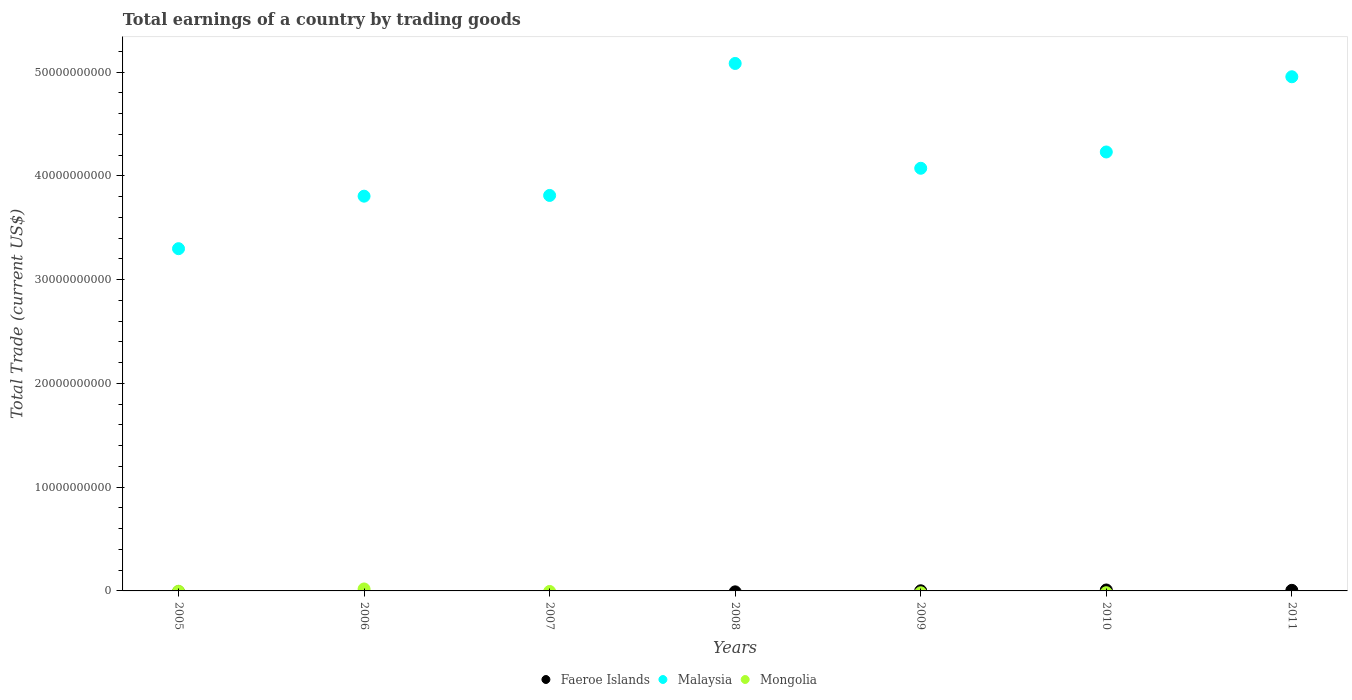How many different coloured dotlines are there?
Your answer should be compact. 3. What is the total earnings in Faeroe Islands in 2011?
Your response must be concise. 5.70e+07. Across all years, what is the maximum total earnings in Faeroe Islands?
Your response must be concise. 9.04e+07. Across all years, what is the minimum total earnings in Faeroe Islands?
Keep it short and to the point. 0. What is the total total earnings in Malaysia in the graph?
Provide a short and direct response. 2.93e+11. What is the difference between the total earnings in Malaysia in 2007 and that in 2011?
Give a very brief answer. -1.14e+1. What is the difference between the total earnings in Malaysia in 2011 and the total earnings in Mongolia in 2007?
Keep it short and to the point. 4.95e+1. What is the average total earnings in Malaysia per year?
Make the answer very short. 4.18e+1. In the year 2010, what is the difference between the total earnings in Faeroe Islands and total earnings in Malaysia?
Keep it short and to the point. -4.22e+1. In how many years, is the total earnings in Mongolia greater than 12000000000 US$?
Provide a succinct answer. 0. What is the ratio of the total earnings in Malaysia in 2005 to that in 2008?
Make the answer very short. 0.65. What is the difference between the highest and the second highest total earnings in Malaysia?
Provide a succinct answer. 1.28e+09. What is the difference between the highest and the lowest total earnings in Malaysia?
Make the answer very short. 1.78e+1. In how many years, is the total earnings in Mongolia greater than the average total earnings in Mongolia taken over all years?
Offer a very short reply. 1. Is the sum of the total earnings in Malaysia in 2005 and 2007 greater than the maximum total earnings in Mongolia across all years?
Ensure brevity in your answer.  Yes. Does the total earnings in Mongolia monotonically increase over the years?
Provide a short and direct response. No. Is the total earnings in Mongolia strictly greater than the total earnings in Malaysia over the years?
Offer a terse response. No. How many years are there in the graph?
Ensure brevity in your answer.  7. What is the difference between two consecutive major ticks on the Y-axis?
Provide a short and direct response. 1.00e+1. Are the values on the major ticks of Y-axis written in scientific E-notation?
Keep it short and to the point. No. Does the graph contain any zero values?
Provide a succinct answer. Yes. How many legend labels are there?
Your answer should be very brief. 3. What is the title of the graph?
Your answer should be very brief. Total earnings of a country by trading goods. What is the label or title of the Y-axis?
Offer a very short reply. Total Trade (current US$). What is the Total Trade (current US$) in Faeroe Islands in 2005?
Your answer should be very brief. 0. What is the Total Trade (current US$) of Malaysia in 2005?
Provide a short and direct response. 3.30e+1. What is the Total Trade (current US$) of Malaysia in 2006?
Make the answer very short. 3.80e+1. What is the Total Trade (current US$) in Mongolia in 2006?
Keep it short and to the point. 1.89e+08. What is the Total Trade (current US$) in Faeroe Islands in 2007?
Your answer should be very brief. 0. What is the Total Trade (current US$) in Malaysia in 2007?
Keep it short and to the point. 3.81e+1. What is the Total Trade (current US$) in Malaysia in 2008?
Your answer should be very brief. 5.08e+1. What is the Total Trade (current US$) in Mongolia in 2008?
Ensure brevity in your answer.  0. What is the Total Trade (current US$) in Faeroe Islands in 2009?
Offer a terse response. 1.31e+07. What is the Total Trade (current US$) of Malaysia in 2009?
Provide a succinct answer. 4.07e+1. What is the Total Trade (current US$) of Mongolia in 2009?
Ensure brevity in your answer.  0. What is the Total Trade (current US$) in Faeroe Islands in 2010?
Your answer should be compact. 9.04e+07. What is the Total Trade (current US$) of Malaysia in 2010?
Provide a short and direct response. 4.23e+1. What is the Total Trade (current US$) in Faeroe Islands in 2011?
Keep it short and to the point. 5.70e+07. What is the Total Trade (current US$) of Malaysia in 2011?
Offer a very short reply. 4.95e+1. What is the Total Trade (current US$) in Mongolia in 2011?
Ensure brevity in your answer.  0. Across all years, what is the maximum Total Trade (current US$) of Faeroe Islands?
Offer a very short reply. 9.04e+07. Across all years, what is the maximum Total Trade (current US$) in Malaysia?
Ensure brevity in your answer.  5.08e+1. Across all years, what is the maximum Total Trade (current US$) in Mongolia?
Keep it short and to the point. 1.89e+08. Across all years, what is the minimum Total Trade (current US$) of Faeroe Islands?
Ensure brevity in your answer.  0. Across all years, what is the minimum Total Trade (current US$) in Malaysia?
Offer a very short reply. 3.30e+1. What is the total Total Trade (current US$) in Faeroe Islands in the graph?
Your answer should be compact. 1.60e+08. What is the total Total Trade (current US$) of Malaysia in the graph?
Ensure brevity in your answer.  2.93e+11. What is the total Total Trade (current US$) of Mongolia in the graph?
Offer a terse response. 1.89e+08. What is the difference between the Total Trade (current US$) in Malaysia in 2005 and that in 2006?
Give a very brief answer. -5.06e+09. What is the difference between the Total Trade (current US$) in Malaysia in 2005 and that in 2007?
Offer a terse response. -5.13e+09. What is the difference between the Total Trade (current US$) of Malaysia in 2005 and that in 2008?
Make the answer very short. -1.78e+1. What is the difference between the Total Trade (current US$) of Malaysia in 2005 and that in 2009?
Your response must be concise. -7.75e+09. What is the difference between the Total Trade (current US$) in Malaysia in 2005 and that in 2010?
Your response must be concise. -9.32e+09. What is the difference between the Total Trade (current US$) in Malaysia in 2005 and that in 2011?
Make the answer very short. -1.66e+1. What is the difference between the Total Trade (current US$) in Malaysia in 2006 and that in 2007?
Your response must be concise. -7.12e+07. What is the difference between the Total Trade (current US$) of Malaysia in 2006 and that in 2008?
Your answer should be very brief. -1.28e+1. What is the difference between the Total Trade (current US$) of Malaysia in 2006 and that in 2009?
Your answer should be very brief. -2.69e+09. What is the difference between the Total Trade (current US$) of Malaysia in 2006 and that in 2010?
Your answer should be very brief. -4.26e+09. What is the difference between the Total Trade (current US$) of Malaysia in 2006 and that in 2011?
Keep it short and to the point. -1.15e+1. What is the difference between the Total Trade (current US$) in Malaysia in 2007 and that in 2008?
Provide a short and direct response. -1.27e+1. What is the difference between the Total Trade (current US$) of Malaysia in 2007 and that in 2009?
Ensure brevity in your answer.  -2.62e+09. What is the difference between the Total Trade (current US$) in Malaysia in 2007 and that in 2010?
Your response must be concise. -4.19e+09. What is the difference between the Total Trade (current US$) of Malaysia in 2007 and that in 2011?
Offer a terse response. -1.14e+1. What is the difference between the Total Trade (current US$) of Malaysia in 2008 and that in 2009?
Make the answer very short. 1.01e+1. What is the difference between the Total Trade (current US$) in Malaysia in 2008 and that in 2010?
Provide a succinct answer. 8.53e+09. What is the difference between the Total Trade (current US$) of Malaysia in 2008 and that in 2011?
Your answer should be very brief. 1.28e+09. What is the difference between the Total Trade (current US$) in Faeroe Islands in 2009 and that in 2010?
Keep it short and to the point. -7.74e+07. What is the difference between the Total Trade (current US$) in Malaysia in 2009 and that in 2010?
Give a very brief answer. -1.57e+09. What is the difference between the Total Trade (current US$) in Faeroe Islands in 2009 and that in 2011?
Make the answer very short. -4.39e+07. What is the difference between the Total Trade (current US$) of Malaysia in 2009 and that in 2011?
Make the answer very short. -8.82e+09. What is the difference between the Total Trade (current US$) in Faeroe Islands in 2010 and that in 2011?
Make the answer very short. 3.35e+07. What is the difference between the Total Trade (current US$) of Malaysia in 2010 and that in 2011?
Offer a very short reply. -7.25e+09. What is the difference between the Total Trade (current US$) in Malaysia in 2005 and the Total Trade (current US$) in Mongolia in 2006?
Your response must be concise. 3.28e+1. What is the difference between the Total Trade (current US$) of Faeroe Islands in 2009 and the Total Trade (current US$) of Malaysia in 2010?
Give a very brief answer. -4.23e+1. What is the difference between the Total Trade (current US$) in Faeroe Islands in 2009 and the Total Trade (current US$) in Malaysia in 2011?
Your answer should be very brief. -4.95e+1. What is the difference between the Total Trade (current US$) in Faeroe Islands in 2010 and the Total Trade (current US$) in Malaysia in 2011?
Provide a succinct answer. -4.95e+1. What is the average Total Trade (current US$) in Faeroe Islands per year?
Your answer should be compact. 2.29e+07. What is the average Total Trade (current US$) in Malaysia per year?
Keep it short and to the point. 4.18e+1. What is the average Total Trade (current US$) of Mongolia per year?
Offer a terse response. 2.69e+07. In the year 2006, what is the difference between the Total Trade (current US$) of Malaysia and Total Trade (current US$) of Mongolia?
Provide a succinct answer. 3.79e+1. In the year 2009, what is the difference between the Total Trade (current US$) in Faeroe Islands and Total Trade (current US$) in Malaysia?
Your answer should be compact. -4.07e+1. In the year 2010, what is the difference between the Total Trade (current US$) in Faeroe Islands and Total Trade (current US$) in Malaysia?
Your answer should be compact. -4.22e+1. In the year 2011, what is the difference between the Total Trade (current US$) in Faeroe Islands and Total Trade (current US$) in Malaysia?
Keep it short and to the point. -4.95e+1. What is the ratio of the Total Trade (current US$) in Malaysia in 2005 to that in 2006?
Provide a succinct answer. 0.87. What is the ratio of the Total Trade (current US$) in Malaysia in 2005 to that in 2007?
Make the answer very short. 0.87. What is the ratio of the Total Trade (current US$) in Malaysia in 2005 to that in 2008?
Provide a short and direct response. 0.65. What is the ratio of the Total Trade (current US$) in Malaysia in 2005 to that in 2009?
Make the answer very short. 0.81. What is the ratio of the Total Trade (current US$) in Malaysia in 2005 to that in 2010?
Provide a short and direct response. 0.78. What is the ratio of the Total Trade (current US$) of Malaysia in 2005 to that in 2011?
Make the answer very short. 0.67. What is the ratio of the Total Trade (current US$) in Malaysia in 2006 to that in 2007?
Give a very brief answer. 1. What is the ratio of the Total Trade (current US$) of Malaysia in 2006 to that in 2008?
Make the answer very short. 0.75. What is the ratio of the Total Trade (current US$) of Malaysia in 2006 to that in 2009?
Make the answer very short. 0.93. What is the ratio of the Total Trade (current US$) of Malaysia in 2006 to that in 2010?
Give a very brief answer. 0.9. What is the ratio of the Total Trade (current US$) in Malaysia in 2006 to that in 2011?
Your answer should be compact. 0.77. What is the ratio of the Total Trade (current US$) of Malaysia in 2007 to that in 2008?
Offer a terse response. 0.75. What is the ratio of the Total Trade (current US$) in Malaysia in 2007 to that in 2009?
Your response must be concise. 0.94. What is the ratio of the Total Trade (current US$) in Malaysia in 2007 to that in 2010?
Provide a succinct answer. 0.9. What is the ratio of the Total Trade (current US$) of Malaysia in 2007 to that in 2011?
Your answer should be very brief. 0.77. What is the ratio of the Total Trade (current US$) of Malaysia in 2008 to that in 2009?
Provide a short and direct response. 1.25. What is the ratio of the Total Trade (current US$) of Malaysia in 2008 to that in 2010?
Keep it short and to the point. 1.2. What is the ratio of the Total Trade (current US$) of Malaysia in 2008 to that in 2011?
Make the answer very short. 1.03. What is the ratio of the Total Trade (current US$) of Faeroe Islands in 2009 to that in 2010?
Your answer should be compact. 0.14. What is the ratio of the Total Trade (current US$) of Malaysia in 2009 to that in 2010?
Ensure brevity in your answer.  0.96. What is the ratio of the Total Trade (current US$) in Faeroe Islands in 2009 to that in 2011?
Offer a terse response. 0.23. What is the ratio of the Total Trade (current US$) in Malaysia in 2009 to that in 2011?
Keep it short and to the point. 0.82. What is the ratio of the Total Trade (current US$) of Faeroe Islands in 2010 to that in 2011?
Provide a succinct answer. 1.59. What is the ratio of the Total Trade (current US$) in Malaysia in 2010 to that in 2011?
Your response must be concise. 0.85. What is the difference between the highest and the second highest Total Trade (current US$) of Faeroe Islands?
Your answer should be very brief. 3.35e+07. What is the difference between the highest and the second highest Total Trade (current US$) of Malaysia?
Keep it short and to the point. 1.28e+09. What is the difference between the highest and the lowest Total Trade (current US$) in Faeroe Islands?
Your answer should be compact. 9.04e+07. What is the difference between the highest and the lowest Total Trade (current US$) in Malaysia?
Keep it short and to the point. 1.78e+1. What is the difference between the highest and the lowest Total Trade (current US$) of Mongolia?
Provide a succinct answer. 1.89e+08. 